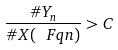<formula> <loc_0><loc_0><loc_500><loc_500>\frac { \# Y _ { n } } { \# X ( \ F q n ) } > C</formula> 